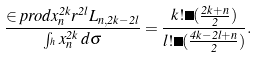<formula> <loc_0><loc_0><loc_500><loc_500>\frac { \in p r o d { x _ { n } ^ { 2 k } } { r ^ { 2 l } L _ { n , 2 k - 2 l } } } { \int _ { ^ { h } } x _ { n } ^ { 2 k } \, d \sigma } = \frac { k ! \Gamma ( \frac { 2 k + n } { 2 } ) } { l ! \Gamma ( \frac { 4 k - 2 l + n } { 2 } ) } .</formula> 